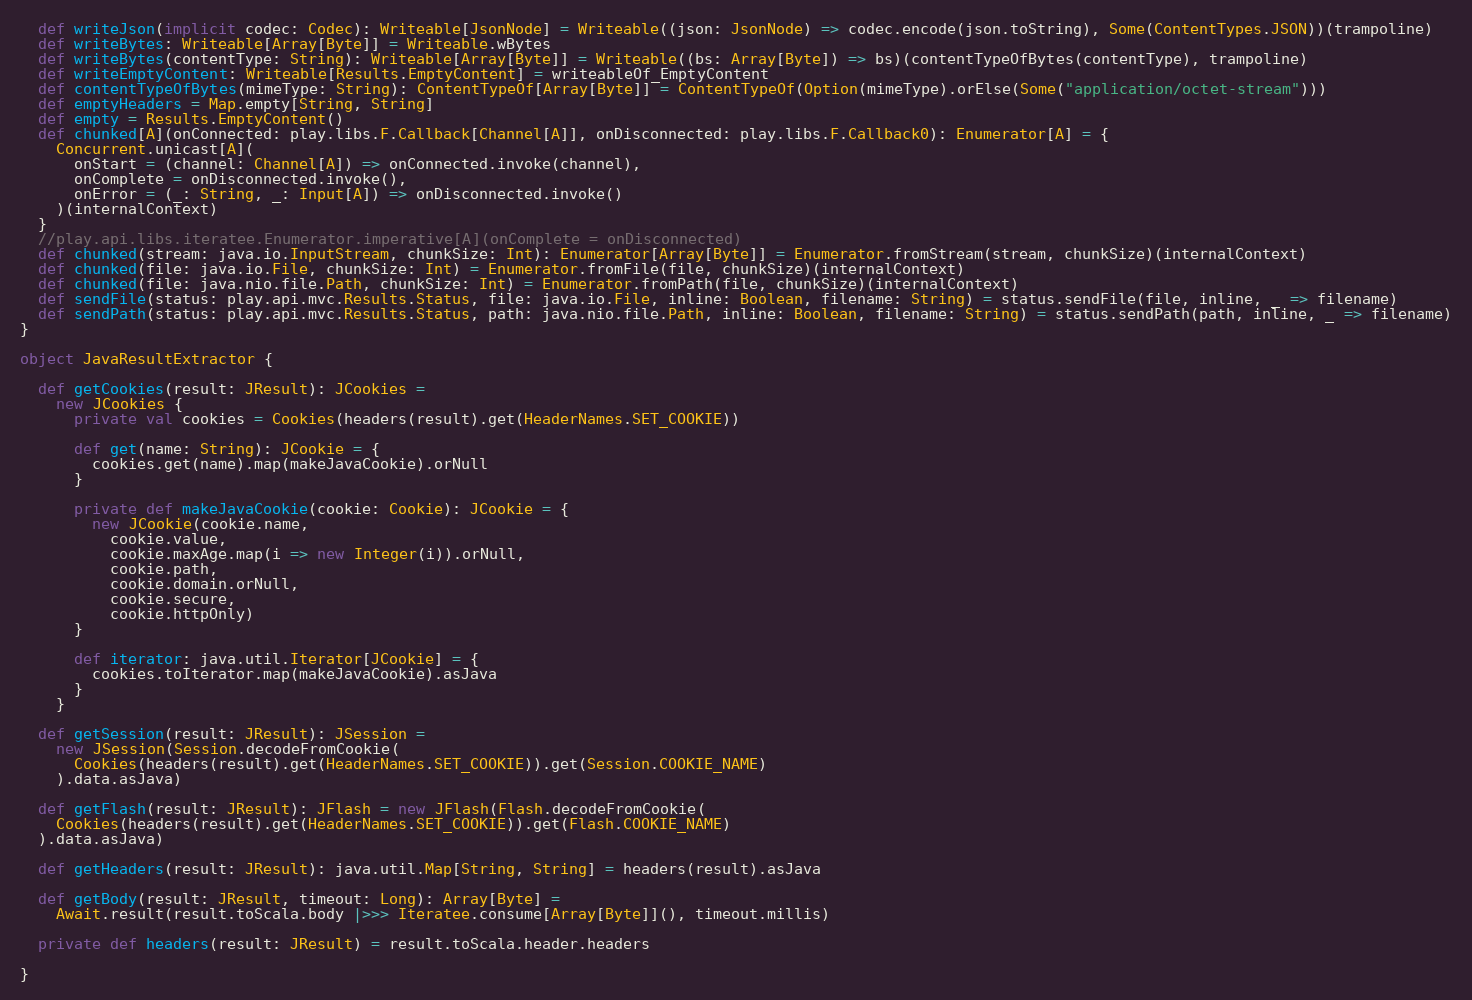Convert code to text. <code><loc_0><loc_0><loc_500><loc_500><_Scala_>  def writeJson(implicit codec: Codec): Writeable[JsonNode] = Writeable((json: JsonNode) => codec.encode(json.toString), Some(ContentTypes.JSON))(trampoline)
  def writeBytes: Writeable[Array[Byte]] = Writeable.wBytes
  def writeBytes(contentType: String): Writeable[Array[Byte]] = Writeable((bs: Array[Byte]) => bs)(contentTypeOfBytes(contentType), trampoline)
  def writeEmptyContent: Writeable[Results.EmptyContent] = writeableOf_EmptyContent
  def contentTypeOfBytes(mimeType: String): ContentTypeOf[Array[Byte]] = ContentTypeOf(Option(mimeType).orElse(Some("application/octet-stream")))
  def emptyHeaders = Map.empty[String, String]
  def empty = Results.EmptyContent()
  def chunked[A](onConnected: play.libs.F.Callback[Channel[A]], onDisconnected: play.libs.F.Callback0): Enumerator[A] = {
    Concurrent.unicast[A](
      onStart = (channel: Channel[A]) => onConnected.invoke(channel),
      onComplete = onDisconnected.invoke(),
      onError = (_: String, _: Input[A]) => onDisconnected.invoke()
    )(internalContext)
  }
  //play.api.libs.iteratee.Enumerator.imperative[A](onComplete = onDisconnected)
  def chunked(stream: java.io.InputStream, chunkSize: Int): Enumerator[Array[Byte]] = Enumerator.fromStream(stream, chunkSize)(internalContext)
  def chunked(file: java.io.File, chunkSize: Int) = Enumerator.fromFile(file, chunkSize)(internalContext)
  def chunked(file: java.nio.file.Path, chunkSize: Int) = Enumerator.fromPath(file, chunkSize)(internalContext)
  def sendFile(status: play.api.mvc.Results.Status, file: java.io.File, inline: Boolean, filename: String) = status.sendFile(file, inline, _ => filename)
  def sendPath(status: play.api.mvc.Results.Status, path: java.nio.file.Path, inline: Boolean, filename: String) = status.sendPath(path, inline, _ => filename)
}

object JavaResultExtractor {

  def getCookies(result: JResult): JCookies =
    new JCookies {
      private val cookies = Cookies(headers(result).get(HeaderNames.SET_COOKIE))

      def get(name: String): JCookie = {
        cookies.get(name).map(makeJavaCookie).orNull
      }

      private def makeJavaCookie(cookie: Cookie): JCookie = {
        new JCookie(cookie.name,
          cookie.value,
          cookie.maxAge.map(i => new Integer(i)).orNull,
          cookie.path,
          cookie.domain.orNull,
          cookie.secure,
          cookie.httpOnly)
      }

      def iterator: java.util.Iterator[JCookie] = {
        cookies.toIterator.map(makeJavaCookie).asJava
      }
    }

  def getSession(result: JResult): JSession =
    new JSession(Session.decodeFromCookie(
      Cookies(headers(result).get(HeaderNames.SET_COOKIE)).get(Session.COOKIE_NAME)
    ).data.asJava)

  def getFlash(result: JResult): JFlash = new JFlash(Flash.decodeFromCookie(
    Cookies(headers(result).get(HeaderNames.SET_COOKIE)).get(Flash.COOKIE_NAME)
  ).data.asJava)

  def getHeaders(result: JResult): java.util.Map[String, String] = headers(result).asJava

  def getBody(result: JResult, timeout: Long): Array[Byte] =
    Await.result(result.toScala.body |>>> Iteratee.consume[Array[Byte]](), timeout.millis)

  private def headers(result: JResult) = result.toScala.header.headers

}
</code> 